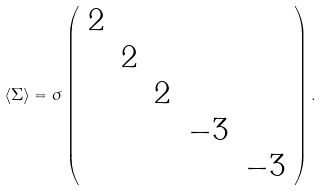Convert formula to latex. <formula><loc_0><loc_0><loc_500><loc_500>\langle \Sigma \rangle = \sigma \left ( \begin{array} { c c c c c } 2 & & & & \\ & 2 & & & \\ & & 2 & & \\ & & & - 3 & \\ & & & & - 3 \end{array} \right ) .</formula> 